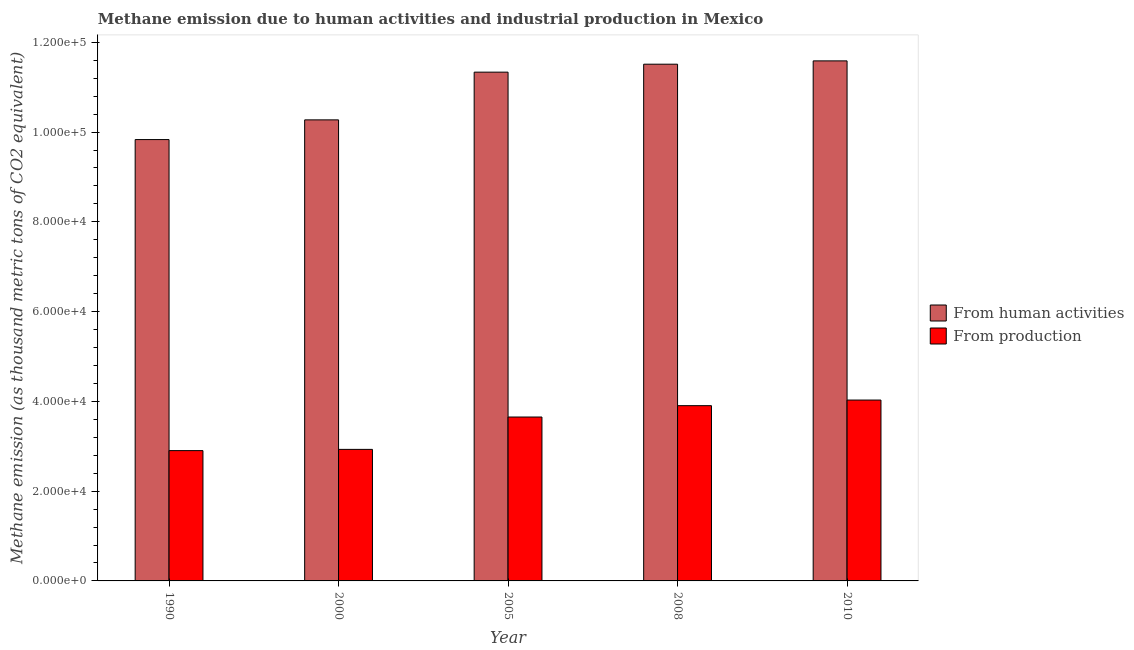How many different coloured bars are there?
Keep it short and to the point. 2. How many groups of bars are there?
Make the answer very short. 5. Are the number of bars per tick equal to the number of legend labels?
Offer a very short reply. Yes. What is the label of the 3rd group of bars from the left?
Offer a very short reply. 2005. In how many cases, is the number of bars for a given year not equal to the number of legend labels?
Your answer should be compact. 0. What is the amount of emissions from human activities in 2000?
Your response must be concise. 1.03e+05. Across all years, what is the maximum amount of emissions generated from industries?
Your response must be concise. 4.03e+04. Across all years, what is the minimum amount of emissions from human activities?
Provide a succinct answer. 9.83e+04. In which year was the amount of emissions from human activities maximum?
Ensure brevity in your answer.  2010. What is the total amount of emissions from human activities in the graph?
Offer a terse response. 5.45e+05. What is the difference between the amount of emissions from human activities in 2000 and that in 2008?
Ensure brevity in your answer.  -1.24e+04. What is the difference between the amount of emissions from human activities in 1990 and the amount of emissions generated from industries in 2000?
Your response must be concise. -4388.4. What is the average amount of emissions generated from industries per year?
Your answer should be very brief. 3.48e+04. In the year 2000, what is the difference between the amount of emissions generated from industries and amount of emissions from human activities?
Your answer should be very brief. 0. What is the ratio of the amount of emissions generated from industries in 1990 to that in 2010?
Offer a terse response. 0.72. Is the amount of emissions from human activities in 1990 less than that in 2010?
Your answer should be compact. Yes. What is the difference between the highest and the second highest amount of emissions from human activities?
Your response must be concise. 738.6. What is the difference between the highest and the lowest amount of emissions generated from industries?
Provide a succinct answer. 1.13e+04. Is the sum of the amount of emissions generated from industries in 1990 and 2010 greater than the maximum amount of emissions from human activities across all years?
Ensure brevity in your answer.  Yes. What does the 1st bar from the left in 2010 represents?
Offer a terse response. From human activities. What does the 2nd bar from the right in 2000 represents?
Ensure brevity in your answer.  From human activities. What is the difference between two consecutive major ticks on the Y-axis?
Ensure brevity in your answer.  2.00e+04. Does the graph contain any zero values?
Your answer should be very brief. No. Does the graph contain grids?
Ensure brevity in your answer.  No. Where does the legend appear in the graph?
Ensure brevity in your answer.  Center right. How are the legend labels stacked?
Your response must be concise. Vertical. What is the title of the graph?
Your answer should be very brief. Methane emission due to human activities and industrial production in Mexico. Does "Methane emissions" appear as one of the legend labels in the graph?
Provide a succinct answer. No. What is the label or title of the X-axis?
Ensure brevity in your answer.  Year. What is the label or title of the Y-axis?
Provide a short and direct response. Methane emission (as thousand metric tons of CO2 equivalent). What is the Methane emission (as thousand metric tons of CO2 equivalent) of From human activities in 1990?
Offer a very short reply. 9.83e+04. What is the Methane emission (as thousand metric tons of CO2 equivalent) in From production in 1990?
Provide a succinct answer. 2.90e+04. What is the Methane emission (as thousand metric tons of CO2 equivalent) of From human activities in 2000?
Offer a terse response. 1.03e+05. What is the Methane emission (as thousand metric tons of CO2 equivalent) of From production in 2000?
Provide a succinct answer. 2.93e+04. What is the Methane emission (as thousand metric tons of CO2 equivalent) in From human activities in 2005?
Make the answer very short. 1.13e+05. What is the Methane emission (as thousand metric tons of CO2 equivalent) of From production in 2005?
Give a very brief answer. 3.65e+04. What is the Methane emission (as thousand metric tons of CO2 equivalent) of From human activities in 2008?
Provide a succinct answer. 1.15e+05. What is the Methane emission (as thousand metric tons of CO2 equivalent) of From production in 2008?
Keep it short and to the point. 3.90e+04. What is the Methane emission (as thousand metric tons of CO2 equivalent) of From human activities in 2010?
Give a very brief answer. 1.16e+05. What is the Methane emission (as thousand metric tons of CO2 equivalent) in From production in 2010?
Give a very brief answer. 4.03e+04. Across all years, what is the maximum Methane emission (as thousand metric tons of CO2 equivalent) in From human activities?
Your answer should be compact. 1.16e+05. Across all years, what is the maximum Methane emission (as thousand metric tons of CO2 equivalent) of From production?
Your response must be concise. 4.03e+04. Across all years, what is the minimum Methane emission (as thousand metric tons of CO2 equivalent) of From human activities?
Your answer should be very brief. 9.83e+04. Across all years, what is the minimum Methane emission (as thousand metric tons of CO2 equivalent) of From production?
Provide a short and direct response. 2.90e+04. What is the total Methane emission (as thousand metric tons of CO2 equivalent) in From human activities in the graph?
Give a very brief answer. 5.45e+05. What is the total Methane emission (as thousand metric tons of CO2 equivalent) of From production in the graph?
Give a very brief answer. 1.74e+05. What is the difference between the Methane emission (as thousand metric tons of CO2 equivalent) in From human activities in 1990 and that in 2000?
Make the answer very short. -4388.4. What is the difference between the Methane emission (as thousand metric tons of CO2 equivalent) in From production in 1990 and that in 2000?
Make the answer very short. -274.1. What is the difference between the Methane emission (as thousand metric tons of CO2 equivalent) in From human activities in 1990 and that in 2005?
Give a very brief answer. -1.50e+04. What is the difference between the Methane emission (as thousand metric tons of CO2 equivalent) of From production in 1990 and that in 2005?
Keep it short and to the point. -7482. What is the difference between the Methane emission (as thousand metric tons of CO2 equivalent) of From human activities in 1990 and that in 2008?
Give a very brief answer. -1.68e+04. What is the difference between the Methane emission (as thousand metric tons of CO2 equivalent) in From production in 1990 and that in 2008?
Ensure brevity in your answer.  -1.00e+04. What is the difference between the Methane emission (as thousand metric tons of CO2 equivalent) of From human activities in 1990 and that in 2010?
Provide a short and direct response. -1.75e+04. What is the difference between the Methane emission (as thousand metric tons of CO2 equivalent) in From production in 1990 and that in 2010?
Your answer should be compact. -1.13e+04. What is the difference between the Methane emission (as thousand metric tons of CO2 equivalent) in From human activities in 2000 and that in 2005?
Give a very brief answer. -1.06e+04. What is the difference between the Methane emission (as thousand metric tons of CO2 equivalent) of From production in 2000 and that in 2005?
Your response must be concise. -7207.9. What is the difference between the Methane emission (as thousand metric tons of CO2 equivalent) in From human activities in 2000 and that in 2008?
Your answer should be compact. -1.24e+04. What is the difference between the Methane emission (as thousand metric tons of CO2 equivalent) in From production in 2000 and that in 2008?
Your answer should be compact. -9739.6. What is the difference between the Methane emission (as thousand metric tons of CO2 equivalent) of From human activities in 2000 and that in 2010?
Ensure brevity in your answer.  -1.31e+04. What is the difference between the Methane emission (as thousand metric tons of CO2 equivalent) of From production in 2000 and that in 2010?
Your answer should be very brief. -1.10e+04. What is the difference between the Methane emission (as thousand metric tons of CO2 equivalent) of From human activities in 2005 and that in 2008?
Provide a short and direct response. -1773.1. What is the difference between the Methane emission (as thousand metric tons of CO2 equivalent) in From production in 2005 and that in 2008?
Make the answer very short. -2531.7. What is the difference between the Methane emission (as thousand metric tons of CO2 equivalent) in From human activities in 2005 and that in 2010?
Give a very brief answer. -2511.7. What is the difference between the Methane emission (as thousand metric tons of CO2 equivalent) in From production in 2005 and that in 2010?
Your response must be concise. -3779.6. What is the difference between the Methane emission (as thousand metric tons of CO2 equivalent) of From human activities in 2008 and that in 2010?
Your answer should be compact. -738.6. What is the difference between the Methane emission (as thousand metric tons of CO2 equivalent) in From production in 2008 and that in 2010?
Offer a terse response. -1247.9. What is the difference between the Methane emission (as thousand metric tons of CO2 equivalent) in From human activities in 1990 and the Methane emission (as thousand metric tons of CO2 equivalent) in From production in 2000?
Give a very brief answer. 6.90e+04. What is the difference between the Methane emission (as thousand metric tons of CO2 equivalent) in From human activities in 1990 and the Methane emission (as thousand metric tons of CO2 equivalent) in From production in 2005?
Keep it short and to the point. 6.18e+04. What is the difference between the Methane emission (as thousand metric tons of CO2 equivalent) in From human activities in 1990 and the Methane emission (as thousand metric tons of CO2 equivalent) in From production in 2008?
Your response must be concise. 5.93e+04. What is the difference between the Methane emission (as thousand metric tons of CO2 equivalent) of From human activities in 1990 and the Methane emission (as thousand metric tons of CO2 equivalent) of From production in 2010?
Provide a short and direct response. 5.80e+04. What is the difference between the Methane emission (as thousand metric tons of CO2 equivalent) of From human activities in 2000 and the Methane emission (as thousand metric tons of CO2 equivalent) of From production in 2005?
Provide a succinct answer. 6.62e+04. What is the difference between the Methane emission (as thousand metric tons of CO2 equivalent) in From human activities in 2000 and the Methane emission (as thousand metric tons of CO2 equivalent) in From production in 2008?
Provide a short and direct response. 6.37e+04. What is the difference between the Methane emission (as thousand metric tons of CO2 equivalent) in From human activities in 2000 and the Methane emission (as thousand metric tons of CO2 equivalent) in From production in 2010?
Your answer should be very brief. 6.24e+04. What is the difference between the Methane emission (as thousand metric tons of CO2 equivalent) of From human activities in 2005 and the Methane emission (as thousand metric tons of CO2 equivalent) of From production in 2008?
Keep it short and to the point. 7.43e+04. What is the difference between the Methane emission (as thousand metric tons of CO2 equivalent) in From human activities in 2005 and the Methane emission (as thousand metric tons of CO2 equivalent) in From production in 2010?
Make the answer very short. 7.31e+04. What is the difference between the Methane emission (as thousand metric tons of CO2 equivalent) of From human activities in 2008 and the Methane emission (as thousand metric tons of CO2 equivalent) of From production in 2010?
Your answer should be compact. 7.48e+04. What is the average Methane emission (as thousand metric tons of CO2 equivalent) of From human activities per year?
Offer a very short reply. 1.09e+05. What is the average Methane emission (as thousand metric tons of CO2 equivalent) of From production per year?
Your answer should be compact. 3.48e+04. In the year 1990, what is the difference between the Methane emission (as thousand metric tons of CO2 equivalent) of From human activities and Methane emission (as thousand metric tons of CO2 equivalent) of From production?
Offer a very short reply. 6.93e+04. In the year 2000, what is the difference between the Methane emission (as thousand metric tons of CO2 equivalent) in From human activities and Methane emission (as thousand metric tons of CO2 equivalent) in From production?
Provide a short and direct response. 7.34e+04. In the year 2005, what is the difference between the Methane emission (as thousand metric tons of CO2 equivalent) of From human activities and Methane emission (as thousand metric tons of CO2 equivalent) of From production?
Offer a terse response. 7.68e+04. In the year 2008, what is the difference between the Methane emission (as thousand metric tons of CO2 equivalent) of From human activities and Methane emission (as thousand metric tons of CO2 equivalent) of From production?
Make the answer very short. 7.61e+04. In the year 2010, what is the difference between the Methane emission (as thousand metric tons of CO2 equivalent) in From human activities and Methane emission (as thousand metric tons of CO2 equivalent) in From production?
Offer a terse response. 7.56e+04. What is the ratio of the Methane emission (as thousand metric tons of CO2 equivalent) of From human activities in 1990 to that in 2000?
Your answer should be compact. 0.96. What is the ratio of the Methane emission (as thousand metric tons of CO2 equivalent) in From production in 1990 to that in 2000?
Offer a terse response. 0.99. What is the ratio of the Methane emission (as thousand metric tons of CO2 equivalent) in From human activities in 1990 to that in 2005?
Your answer should be compact. 0.87. What is the ratio of the Methane emission (as thousand metric tons of CO2 equivalent) of From production in 1990 to that in 2005?
Offer a terse response. 0.8. What is the ratio of the Methane emission (as thousand metric tons of CO2 equivalent) in From human activities in 1990 to that in 2008?
Provide a succinct answer. 0.85. What is the ratio of the Methane emission (as thousand metric tons of CO2 equivalent) in From production in 1990 to that in 2008?
Provide a succinct answer. 0.74. What is the ratio of the Methane emission (as thousand metric tons of CO2 equivalent) in From human activities in 1990 to that in 2010?
Keep it short and to the point. 0.85. What is the ratio of the Methane emission (as thousand metric tons of CO2 equivalent) of From production in 1990 to that in 2010?
Offer a terse response. 0.72. What is the ratio of the Methane emission (as thousand metric tons of CO2 equivalent) of From human activities in 2000 to that in 2005?
Offer a terse response. 0.91. What is the ratio of the Methane emission (as thousand metric tons of CO2 equivalent) in From production in 2000 to that in 2005?
Give a very brief answer. 0.8. What is the ratio of the Methane emission (as thousand metric tons of CO2 equivalent) in From human activities in 2000 to that in 2008?
Your answer should be very brief. 0.89. What is the ratio of the Methane emission (as thousand metric tons of CO2 equivalent) of From production in 2000 to that in 2008?
Make the answer very short. 0.75. What is the ratio of the Methane emission (as thousand metric tons of CO2 equivalent) in From human activities in 2000 to that in 2010?
Provide a short and direct response. 0.89. What is the ratio of the Methane emission (as thousand metric tons of CO2 equivalent) of From production in 2000 to that in 2010?
Provide a short and direct response. 0.73. What is the ratio of the Methane emission (as thousand metric tons of CO2 equivalent) of From human activities in 2005 to that in 2008?
Provide a short and direct response. 0.98. What is the ratio of the Methane emission (as thousand metric tons of CO2 equivalent) in From production in 2005 to that in 2008?
Give a very brief answer. 0.94. What is the ratio of the Methane emission (as thousand metric tons of CO2 equivalent) in From human activities in 2005 to that in 2010?
Ensure brevity in your answer.  0.98. What is the ratio of the Methane emission (as thousand metric tons of CO2 equivalent) of From production in 2005 to that in 2010?
Your answer should be compact. 0.91. What is the difference between the highest and the second highest Methane emission (as thousand metric tons of CO2 equivalent) in From human activities?
Keep it short and to the point. 738.6. What is the difference between the highest and the second highest Methane emission (as thousand metric tons of CO2 equivalent) of From production?
Provide a succinct answer. 1247.9. What is the difference between the highest and the lowest Methane emission (as thousand metric tons of CO2 equivalent) of From human activities?
Offer a very short reply. 1.75e+04. What is the difference between the highest and the lowest Methane emission (as thousand metric tons of CO2 equivalent) in From production?
Provide a short and direct response. 1.13e+04. 